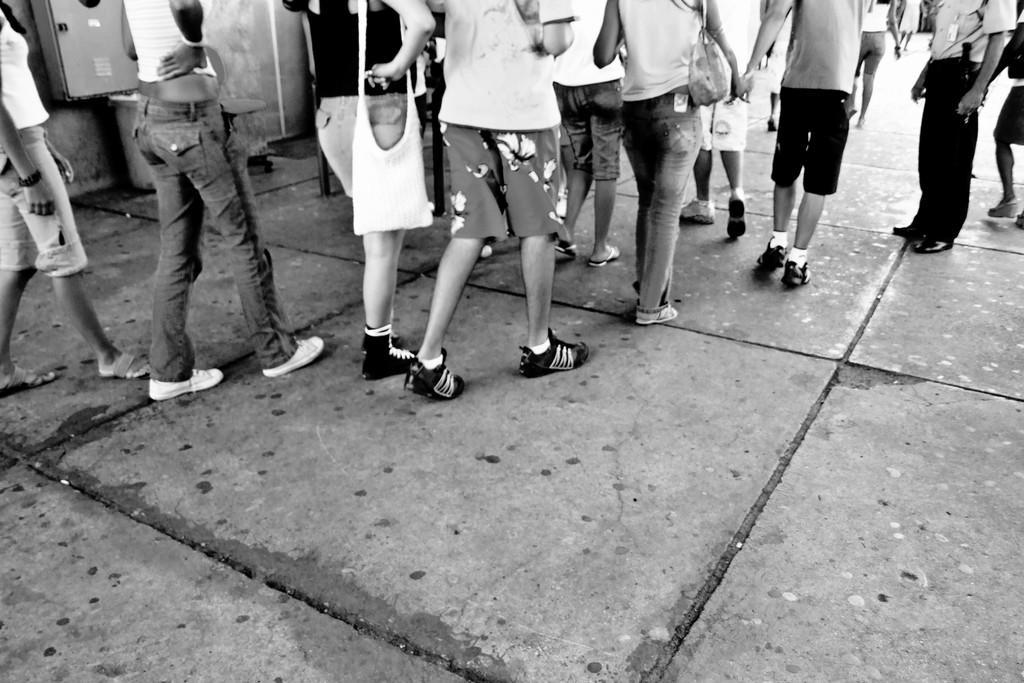Describe this image in one or two sentences. This is a black and white image. In this image we can see persons walking and some are standing on the floor. 